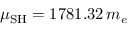<formula> <loc_0><loc_0><loc_500><loc_500>\mu _ { S H } = 1 7 8 1 . 3 2 \, m _ { e }</formula> 